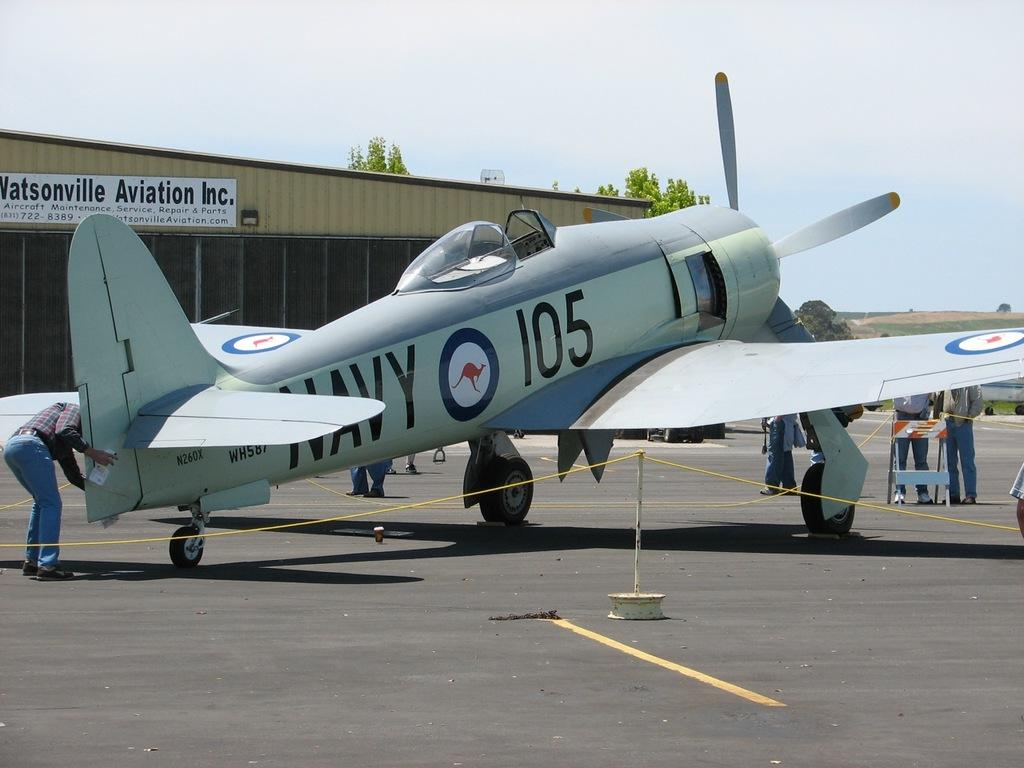<image>
Provide a brief description of the given image. a Navy plane is being cleaned and worked on inside a roped in area 